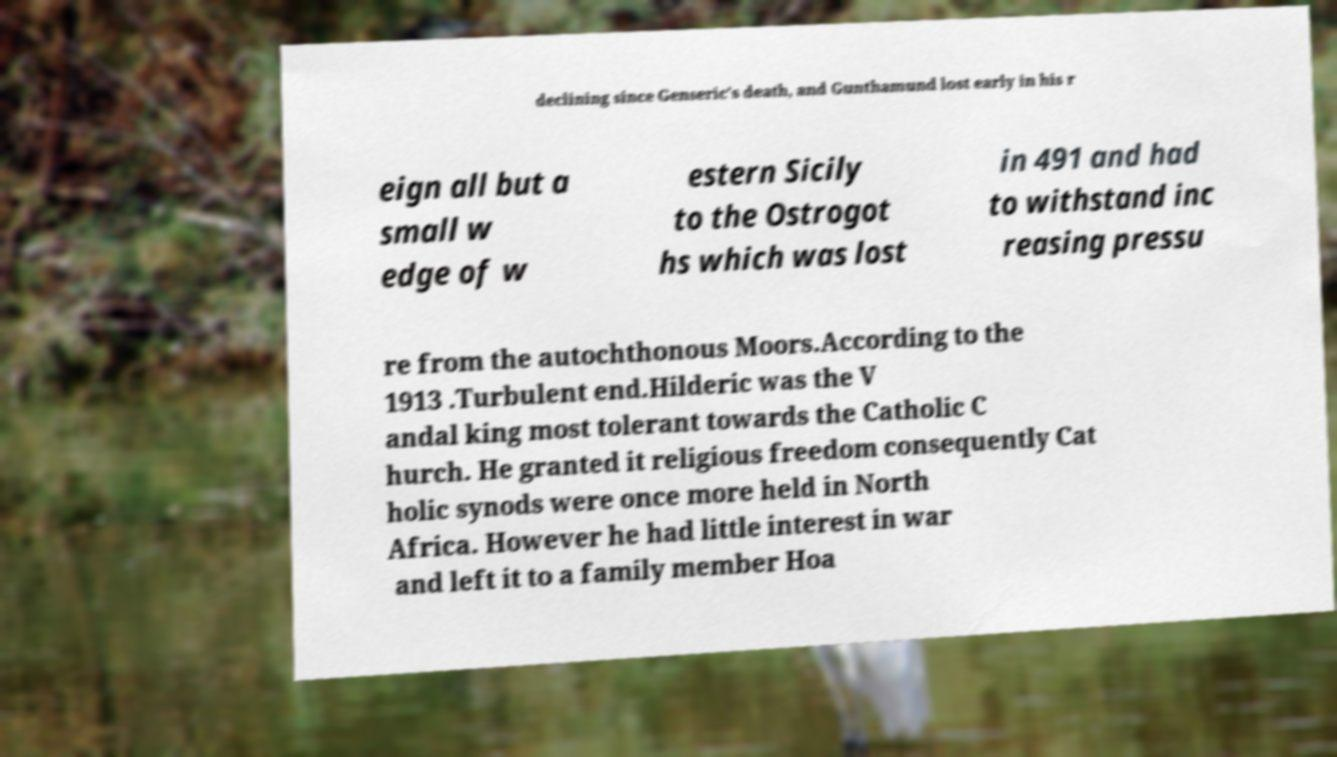What messages or text are displayed in this image? I need them in a readable, typed format. declining since Genseric's death, and Gunthamund lost early in his r eign all but a small w edge of w estern Sicily to the Ostrogot hs which was lost in 491 and had to withstand inc reasing pressu re from the autochthonous Moors.According to the 1913 .Turbulent end.Hilderic was the V andal king most tolerant towards the Catholic C hurch. He granted it religious freedom consequently Cat holic synods were once more held in North Africa. However he had little interest in war and left it to a family member Hoa 